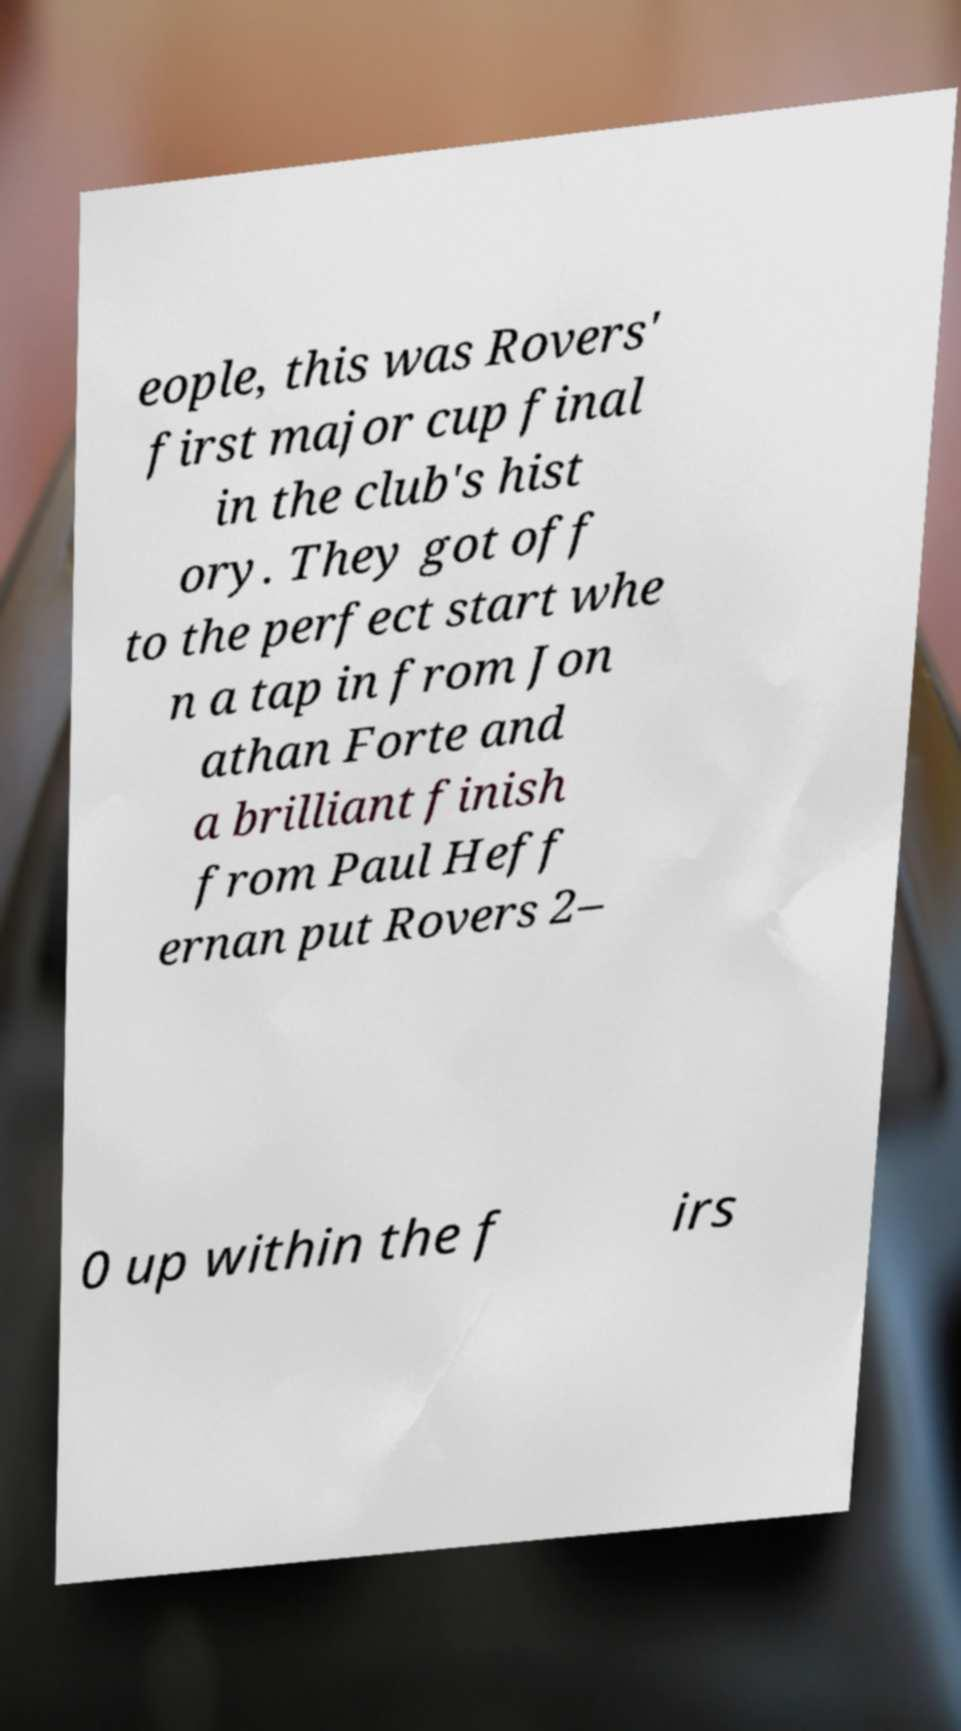There's text embedded in this image that I need extracted. Can you transcribe it verbatim? eople, this was Rovers' first major cup final in the club's hist ory. They got off to the perfect start whe n a tap in from Jon athan Forte and a brilliant finish from Paul Heff ernan put Rovers 2– 0 up within the f irs 